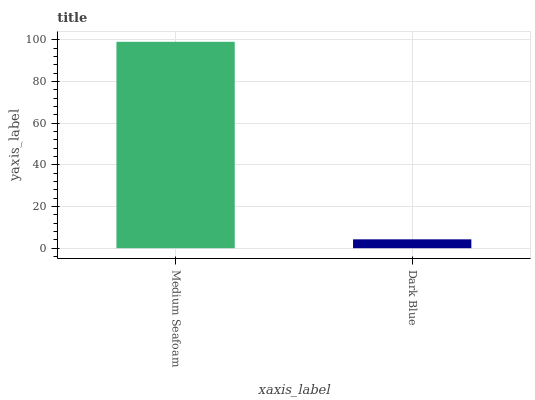Is Dark Blue the minimum?
Answer yes or no. Yes. Is Medium Seafoam the maximum?
Answer yes or no. Yes. Is Dark Blue the maximum?
Answer yes or no. No. Is Medium Seafoam greater than Dark Blue?
Answer yes or no. Yes. Is Dark Blue less than Medium Seafoam?
Answer yes or no. Yes. Is Dark Blue greater than Medium Seafoam?
Answer yes or no. No. Is Medium Seafoam less than Dark Blue?
Answer yes or no. No. Is Medium Seafoam the high median?
Answer yes or no. Yes. Is Dark Blue the low median?
Answer yes or no. Yes. Is Dark Blue the high median?
Answer yes or no. No. Is Medium Seafoam the low median?
Answer yes or no. No. 